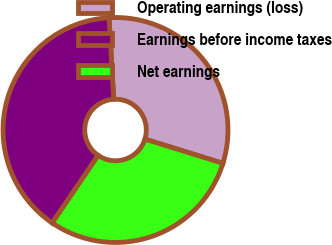<chart> <loc_0><loc_0><loc_500><loc_500><pie_chart><fcel>Operating earnings (loss)<fcel>Earnings before income taxes<fcel>Net earnings<nl><fcel>30.71%<fcel>39.57%<fcel>29.72%<nl></chart> 